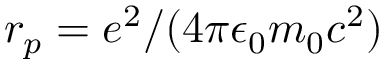Convert formula to latex. <formula><loc_0><loc_0><loc_500><loc_500>r _ { p } = e ^ { 2 } / ( 4 \pi \epsilon _ { 0 } m _ { 0 } c ^ { 2 } )</formula> 